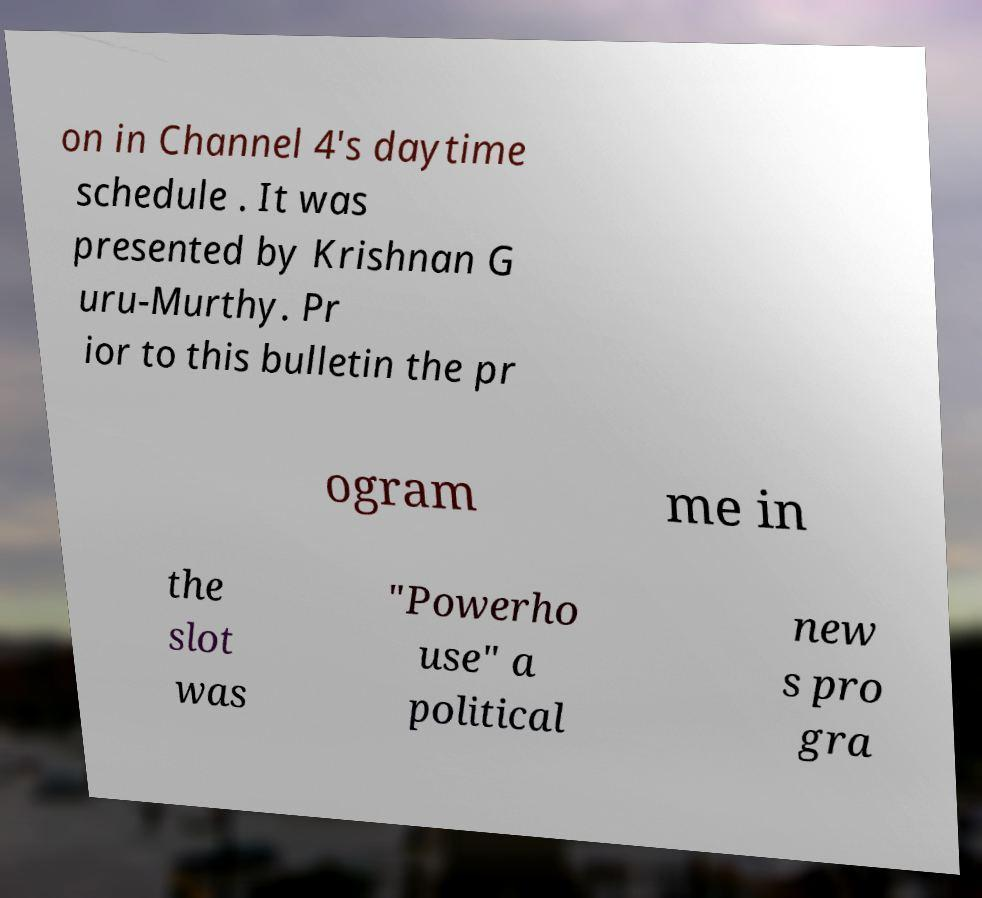Could you assist in decoding the text presented in this image and type it out clearly? on in Channel 4's daytime schedule . It was presented by Krishnan G uru-Murthy. Pr ior to this bulletin the pr ogram me in the slot was "Powerho use" a political new s pro gra 